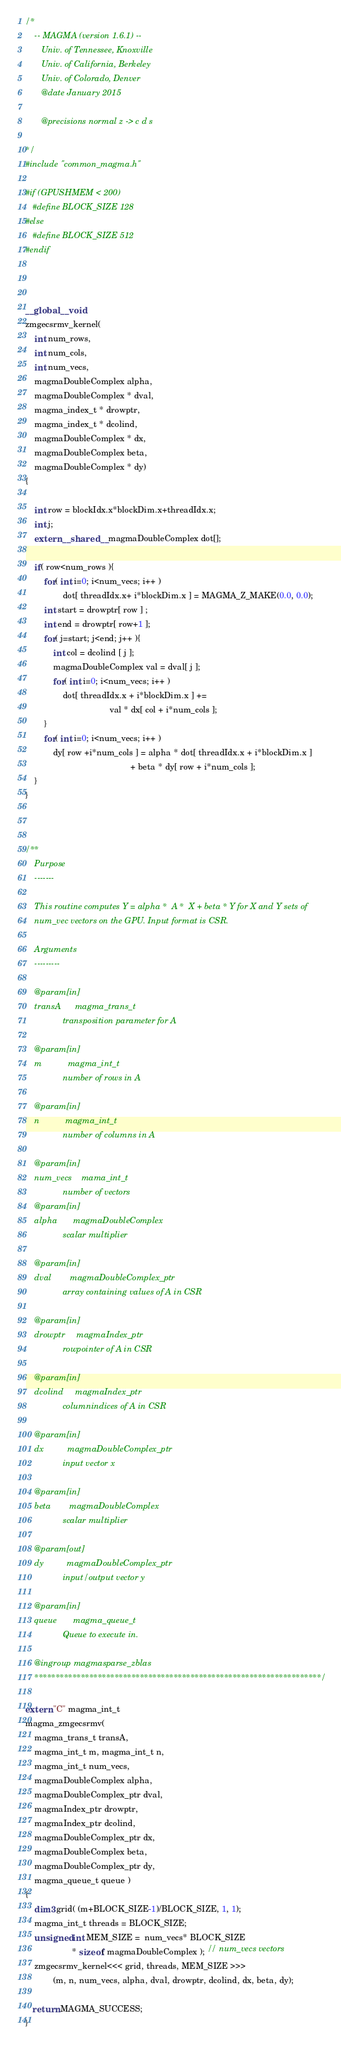Convert code to text. <code><loc_0><loc_0><loc_500><loc_500><_Cuda_>/*
    -- MAGMA (version 1.6.1) --
       Univ. of Tennessee, Knoxville
       Univ. of California, Berkeley
       Univ. of Colorado, Denver
       @date January 2015

       @precisions normal z -> c d s

*/
#include "common_magma.h"

#if (GPUSHMEM < 200)
   #define BLOCK_SIZE 128
#else
   #define BLOCK_SIZE 512
#endif



__global__ void 
zmgecsrmv_kernel( 
    int num_rows, 
    int num_cols, 
    int num_vecs,
    magmaDoubleComplex alpha, 
    magmaDoubleComplex * dval, 
    magma_index_t * drowptr, 
    magma_index_t * dcolind,
    magmaDoubleComplex * dx,
    magmaDoubleComplex beta, 
    magmaDoubleComplex * dy)
{

    int row = blockIdx.x*blockDim.x+threadIdx.x;
    int j;
    extern __shared__ magmaDoubleComplex dot[];

    if( row<num_rows ){
        for( int i=0; i<num_vecs; i++ )
                dot[ threadIdx.x+ i*blockDim.x ] = MAGMA_Z_MAKE(0.0, 0.0);
        int start = drowptr[ row ] ;
        int end = drowptr[ row+1 ];
        for( j=start; j<end; j++ ){
            int col = dcolind [ j ];
            magmaDoubleComplex val = dval[ j ];
            for( int i=0; i<num_vecs; i++ )
                dot[ threadIdx.x + i*blockDim.x ] += 
                                    val * dx[ col + i*num_cols ];
        }
        for( int i=0; i<num_vecs; i++ )
            dy[ row +i*num_cols ] = alpha * dot[ threadIdx.x + i*blockDim.x ] 
                                             + beta * dy[ row + i*num_cols ];
    }
}



/**
    Purpose
    -------
    
    This routine computes Y = alpha *  A *  X + beta * Y for X and Y sets of 
    num_vec vectors on the GPU. Input format is CSR. 
    
    Arguments
    ---------
    
    @param[in]
    transA      magma_trans_t
                transposition parameter for A

    @param[in]
    m           magma_int_t
                number of rows in A

    @param[in]
    n           magma_int_t
                number of columns in A 
                
    @param[in]
    num_vecs    mama_int_t
                number of vectors
    @param[in]
    alpha       magmaDoubleComplex
                scalar multiplier

    @param[in]
    dval        magmaDoubleComplex_ptr
                array containing values of A in CSR

    @param[in]
    drowptr     magmaIndex_ptr
                rowpointer of A in CSR

    @param[in]
    dcolind     magmaIndex_ptr
                columnindices of A in CSR

    @param[in]
    dx          magmaDoubleComplex_ptr
                input vector x

    @param[in]
    beta        magmaDoubleComplex
                scalar multiplier

    @param[out]
    dy          magmaDoubleComplex_ptr
                input/output vector y

    @param[in]
    queue       magma_queue_t
                Queue to execute in.

    @ingroup magmasparse_zblas
    ********************************************************************/

extern "C" magma_int_t
magma_zmgecsrmv(
    magma_trans_t transA,
    magma_int_t m, magma_int_t n,
    magma_int_t num_vecs, 
    magmaDoubleComplex alpha,
    magmaDoubleComplex_ptr dval,
    magmaIndex_ptr drowptr,
    magmaIndex_ptr dcolind,
    magmaDoubleComplex_ptr dx,
    magmaDoubleComplex beta,
    magmaDoubleComplex_ptr dy,
    magma_queue_t queue )
{
    dim3 grid( (m+BLOCK_SIZE-1)/BLOCK_SIZE, 1, 1);
    magma_int_t threads = BLOCK_SIZE;
    unsigned int MEM_SIZE =  num_vecs* BLOCK_SIZE 
                    * sizeof( magmaDoubleComplex ); // num_vecs vectors 
    zmgecsrmv_kernel<<< grid, threads, MEM_SIZE >>>
            (m, n, num_vecs, alpha, dval, drowptr, dcolind, dx, beta, dy);

   return MAGMA_SUCCESS;
}



</code> 